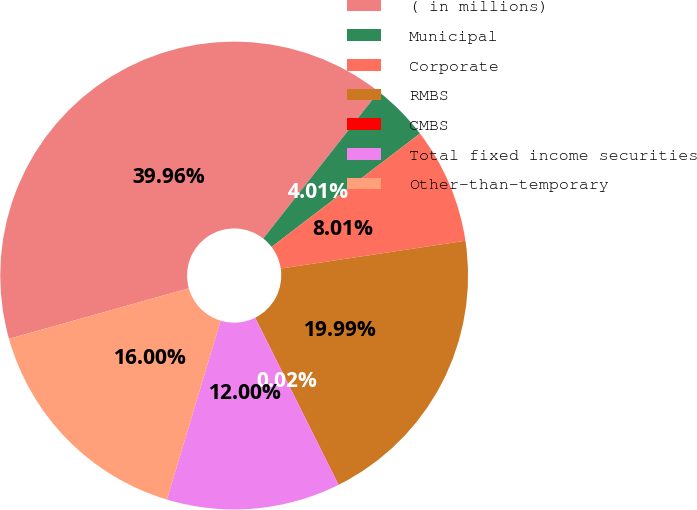Convert chart. <chart><loc_0><loc_0><loc_500><loc_500><pie_chart><fcel>( in millions)<fcel>Municipal<fcel>Corporate<fcel>RMBS<fcel>CMBS<fcel>Total fixed income securities<fcel>Other-than-temporary<nl><fcel>39.96%<fcel>4.01%<fcel>8.01%<fcel>19.99%<fcel>0.02%<fcel>12.0%<fcel>16.0%<nl></chart> 